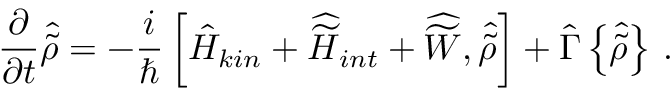<formula> <loc_0><loc_0><loc_500><loc_500>\frac { \partial } { \partial t } { \hat { \tilde { \rho } } } = - \frac { i } { } \left [ { \hat { H } } _ { k i n } + { \widehat { \widetilde { H } } } _ { i n t } + { \widehat { \widetilde { W } } } , { \hat { \tilde { \rho } } } \right ] + { \hat { \Gamma } } \left \{ { \hat { \tilde { \rho } } } \right \} \, .</formula> 